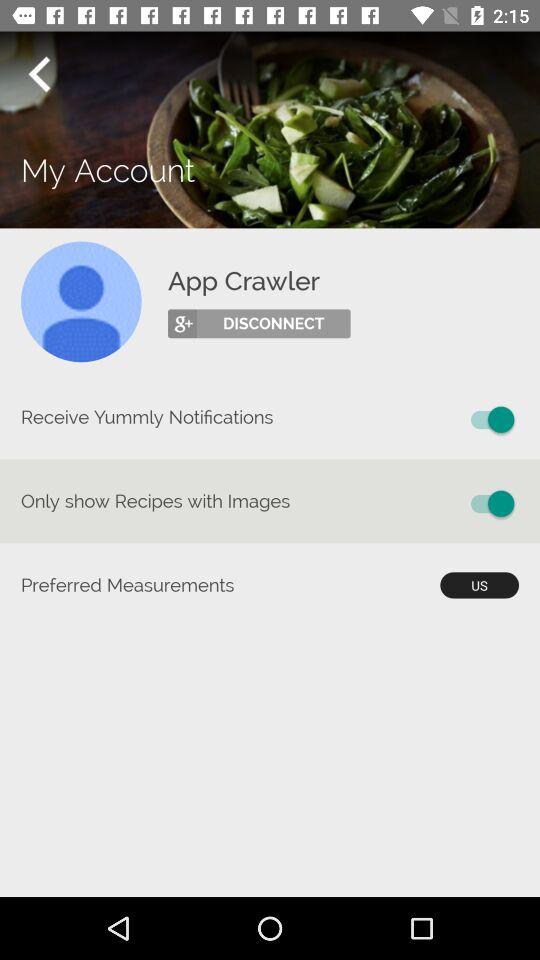Which country is selected in the "Preferred Measurements"? The selected country is the United States. 